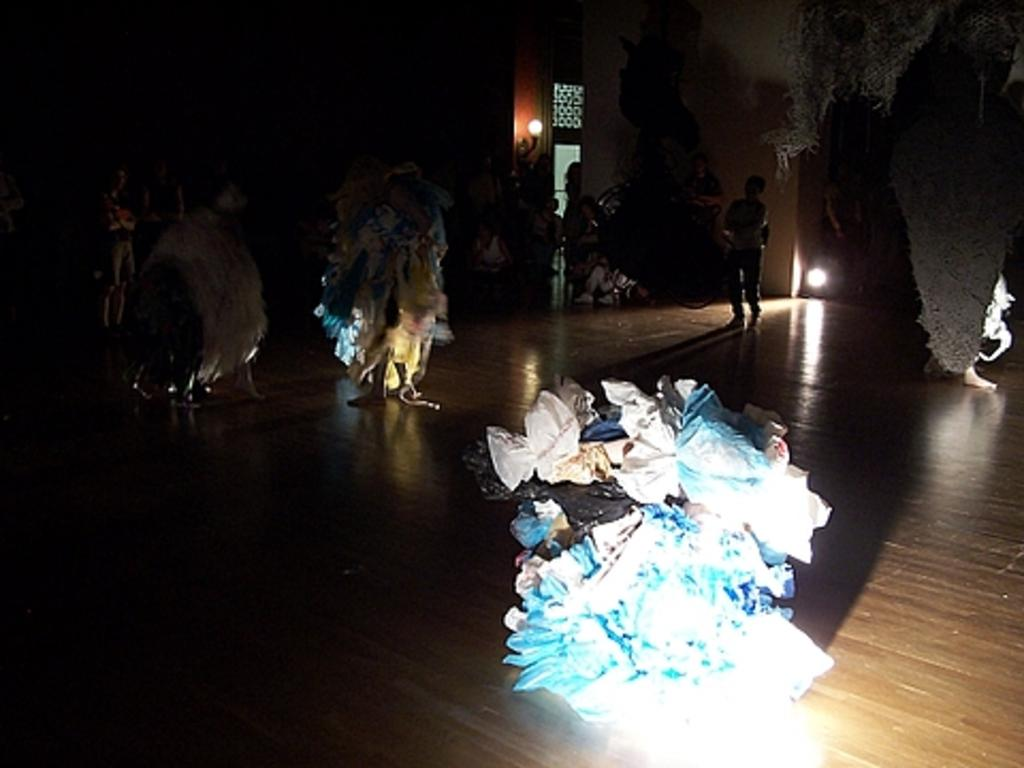What type of objects can be seen in the image? There are colorful objects in the image. What is the color of the floor where the people are standing? The floor is brown in color. Can you describe the lighting in the image? There is a light visible in the image. What is present in the background of the image? There is a wall in the background of the image. What type of sail can be seen on the stranger's boat in the image? There is no boat or stranger present in the image, so it is not possible to answer that question. 